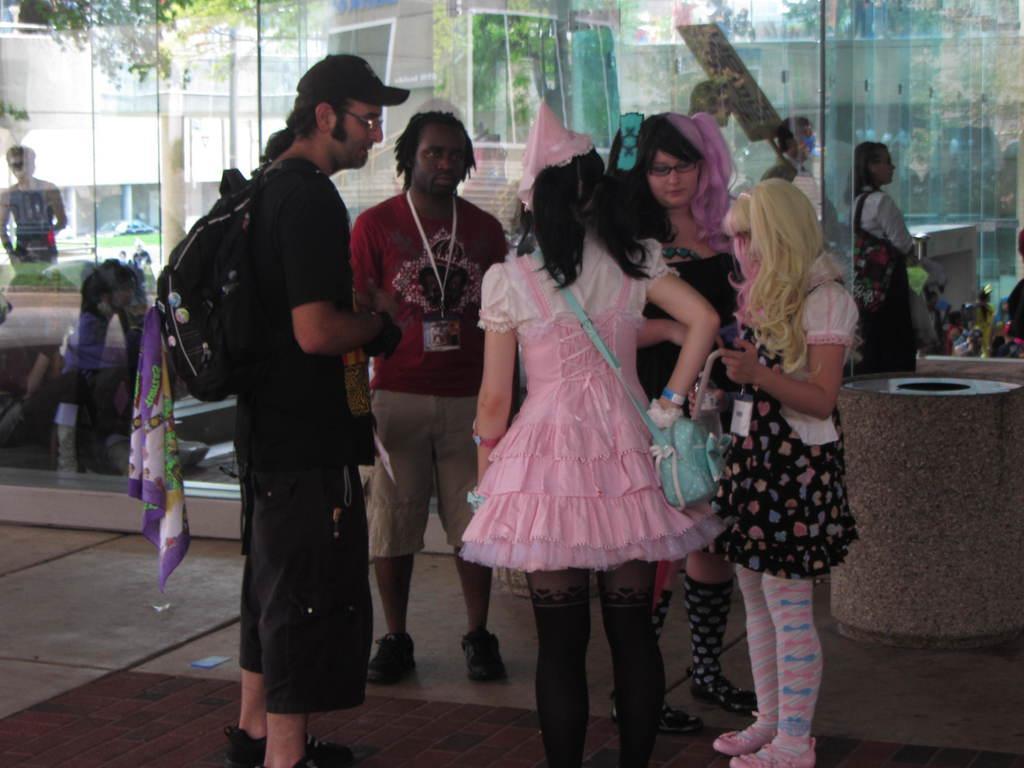Describe this image in one or two sentences. In the middle of the image few people are standing and holding something. Behind them there is a glass wall. Through the glass wall we can see some trees and buildings and vehicles. 